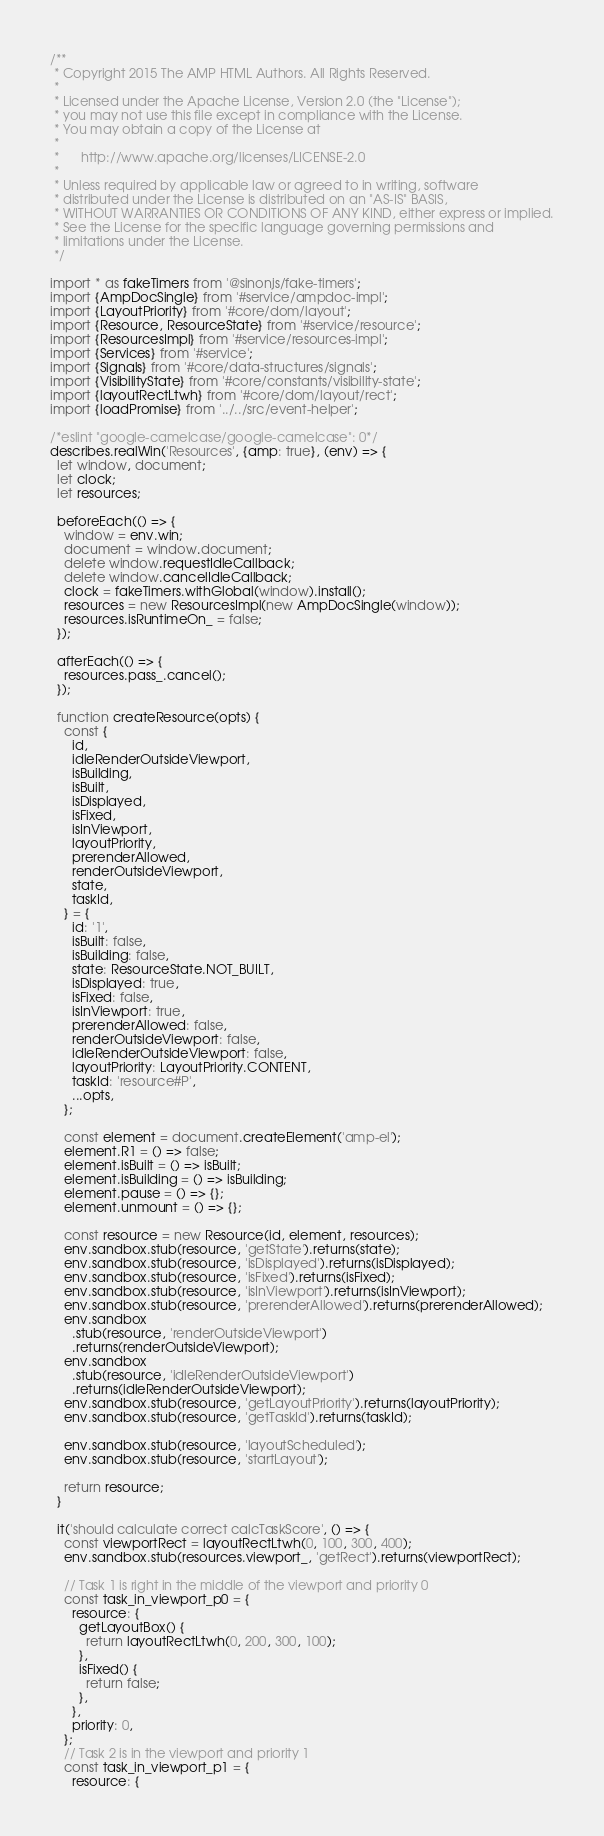Convert code to text. <code><loc_0><loc_0><loc_500><loc_500><_JavaScript_>/**
 * Copyright 2015 The AMP HTML Authors. All Rights Reserved.
 *
 * Licensed under the Apache License, Version 2.0 (the "License");
 * you may not use this file except in compliance with the License.
 * You may obtain a copy of the License at
 *
 *      http://www.apache.org/licenses/LICENSE-2.0
 *
 * Unless required by applicable law or agreed to in writing, software
 * distributed under the License is distributed on an "AS-IS" BASIS,
 * WITHOUT WARRANTIES OR CONDITIONS OF ANY KIND, either express or implied.
 * See the License for the specific language governing permissions and
 * limitations under the License.
 */

import * as fakeTimers from '@sinonjs/fake-timers';
import {AmpDocSingle} from '#service/ampdoc-impl';
import {LayoutPriority} from '#core/dom/layout';
import {Resource, ResourceState} from '#service/resource';
import {ResourcesImpl} from '#service/resources-impl';
import {Services} from '#service';
import {Signals} from '#core/data-structures/signals';
import {VisibilityState} from '#core/constants/visibility-state';
import {layoutRectLtwh} from '#core/dom/layout/rect';
import {loadPromise} from '../../src/event-helper';

/*eslint "google-camelcase/google-camelcase": 0*/
describes.realWin('Resources', {amp: true}, (env) => {
  let window, document;
  let clock;
  let resources;

  beforeEach(() => {
    window = env.win;
    document = window.document;
    delete window.requestIdleCallback;
    delete window.cancelIdleCallback;
    clock = fakeTimers.withGlobal(window).install();
    resources = new ResourcesImpl(new AmpDocSingle(window));
    resources.isRuntimeOn_ = false;
  });

  afterEach(() => {
    resources.pass_.cancel();
  });

  function createResource(opts) {
    const {
      id,
      idleRenderOutsideViewport,
      isBuilding,
      isBuilt,
      isDisplayed,
      isFixed,
      isInViewport,
      layoutPriority,
      prerenderAllowed,
      renderOutsideViewport,
      state,
      taskId,
    } = {
      id: '1',
      isBuilt: false,
      isBuilding: false,
      state: ResourceState.NOT_BUILT,
      isDisplayed: true,
      isFixed: false,
      isInViewport: true,
      prerenderAllowed: false,
      renderOutsideViewport: false,
      idleRenderOutsideViewport: false,
      layoutPriority: LayoutPriority.CONTENT,
      taskId: 'resource#P',
      ...opts,
    };

    const element = document.createElement('amp-el');
    element.R1 = () => false;
    element.isBuilt = () => isBuilt;
    element.isBuilding = () => isBuilding;
    element.pause = () => {};
    element.unmount = () => {};

    const resource = new Resource(id, element, resources);
    env.sandbox.stub(resource, 'getState').returns(state);
    env.sandbox.stub(resource, 'isDisplayed').returns(isDisplayed);
    env.sandbox.stub(resource, 'isFixed').returns(isFixed);
    env.sandbox.stub(resource, 'isInViewport').returns(isInViewport);
    env.sandbox.stub(resource, 'prerenderAllowed').returns(prerenderAllowed);
    env.sandbox
      .stub(resource, 'renderOutsideViewport')
      .returns(renderOutsideViewport);
    env.sandbox
      .stub(resource, 'idleRenderOutsideViewport')
      .returns(idleRenderOutsideViewport);
    env.sandbox.stub(resource, 'getLayoutPriority').returns(layoutPriority);
    env.sandbox.stub(resource, 'getTaskId').returns(taskId);

    env.sandbox.stub(resource, 'layoutScheduled');
    env.sandbox.stub(resource, 'startLayout');

    return resource;
  }

  it('should calculate correct calcTaskScore', () => {
    const viewportRect = layoutRectLtwh(0, 100, 300, 400);
    env.sandbox.stub(resources.viewport_, 'getRect').returns(viewportRect);

    // Task 1 is right in the middle of the viewport and priority 0
    const task_in_viewport_p0 = {
      resource: {
        getLayoutBox() {
          return layoutRectLtwh(0, 200, 300, 100);
        },
        isFixed() {
          return false;
        },
      },
      priority: 0,
    };
    // Task 2 is in the viewport and priority 1
    const task_in_viewport_p1 = {
      resource: {</code> 